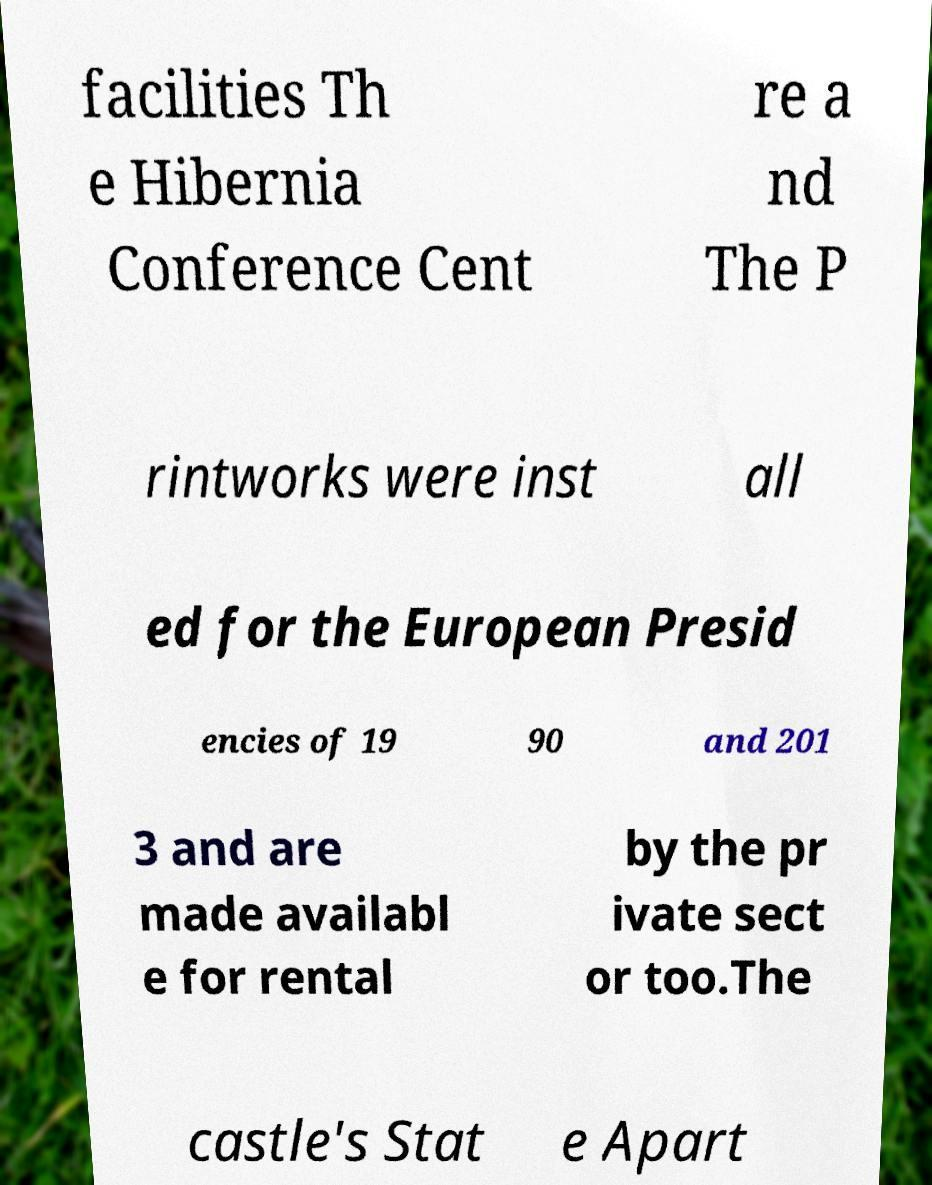Could you assist in decoding the text presented in this image and type it out clearly? facilities Th e Hibernia Conference Cent re a nd The P rintworks were inst all ed for the European Presid encies of 19 90 and 201 3 and are made availabl e for rental by the pr ivate sect or too.The castle's Stat e Apart 